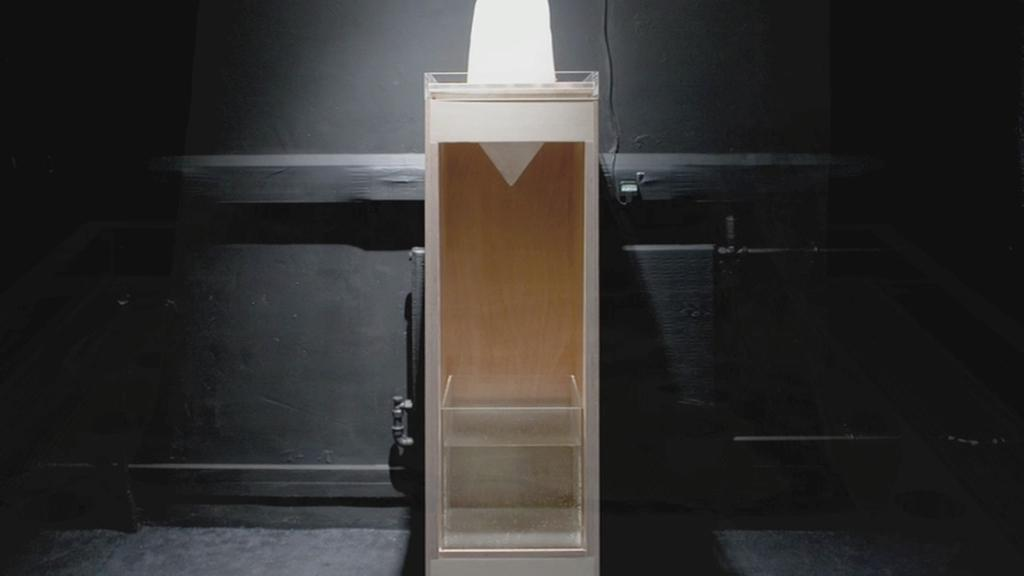What is the color of the object in the image? The object in the image is white. How is the object being contained or displayed? The object is placed in a box, and the box is covered with a glass. What can be seen in the background of the image? There is a wall in the background of the image. What is the color of the background in the image? The background is dark in color. Can you see any rabbits running downtown in the image? There are no rabbits or downtown scenes present in the image. 